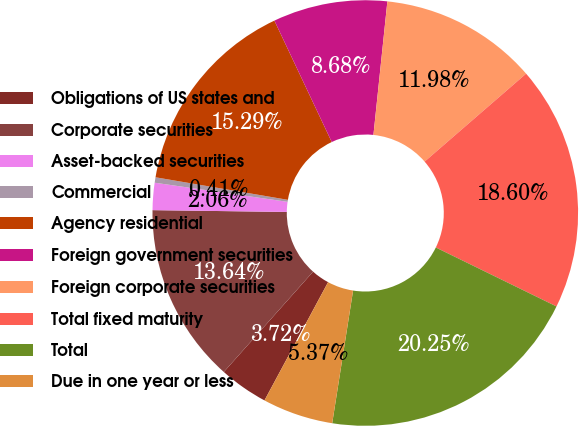<chart> <loc_0><loc_0><loc_500><loc_500><pie_chart><fcel>Obligations of US states and<fcel>Corporate securities<fcel>Asset-backed securities<fcel>Commercial<fcel>Agency residential<fcel>Foreign government securities<fcel>Foreign corporate securities<fcel>Total fixed maturity<fcel>Total<fcel>Due in one year or less<nl><fcel>3.72%<fcel>13.64%<fcel>2.06%<fcel>0.41%<fcel>15.29%<fcel>8.68%<fcel>11.98%<fcel>18.6%<fcel>20.25%<fcel>5.37%<nl></chart> 